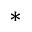Convert formula to latex. <formula><loc_0><loc_0><loc_500><loc_500>^ { \ast }</formula> 